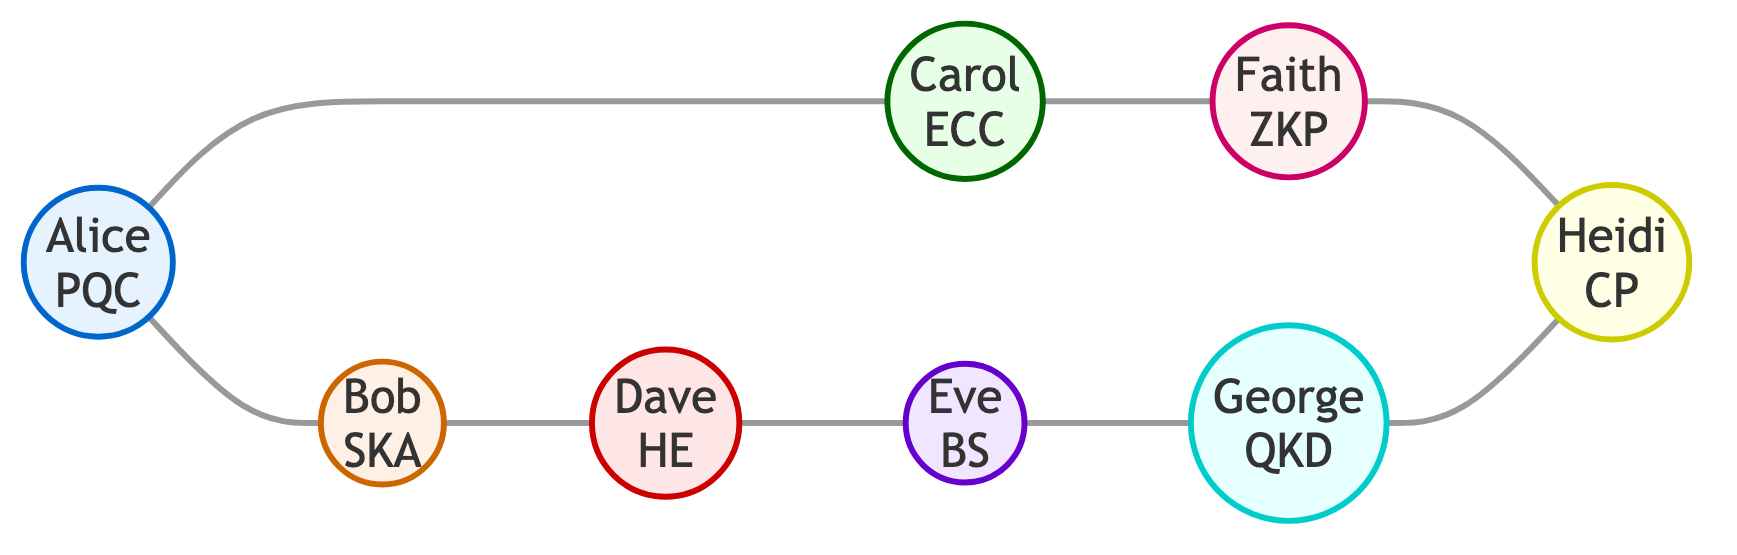What is the total number of nodes in the graph? By counting the distinct individuals represented in the diagram, we see that there are eight unique nodes: Alice, Bob, Carol, Dave, Eve, Faith, George, and Heidi.
Answer: 8 Which cryptographer collaborated with Alice? The edges connected to Alice show that she has collaborated with two individuals: Bob and Carol.
Answer: Bob and Carol What is the collaboration between Dave and Eve? The edge connecting Dave and Eve specifies that they worked together on a paper concerning homomorphic encryption for blockchain technology.
Answer: Paper on homomorphic encryption for blockchain How many different collaboration aspects are represented by the edges? Each edge in the graph represents a different aspect of collaboration between two cryptographers. There are eight edges listed, each representing one aspect of collaboration.
Answer: 8 Who collaborated with Faith? A look at the edges shows that Faith collaborated only with Heidi on a workshop related to cryptographic protocols with zero-knowledge.
Answer: Heidi Which two cryptographic fields are connected through Carol's collaboration? Carol's efforts resulted in collaborations with Faith on zero-knowledge proofs and Alice on post-quantum elliptic curves. The fields represented by these collaborations are zero-knowledge proofs and elliptic curve cryptography.
Answer: Zero-knowledge proofs and elliptic curve cryptography How many collaborations involve blockchain security? Eve's involvement includes one edge, which collaborates with Dave on a paper involving homomorphic encryption for blockchain, indicating that there is one collaboration related to blockchain security.
Answer: 1 Identify a cryptographer who works with quantum key distribution. The diagram reveals that George has collaborated with Heidi on joint research related to quantum key distribution protocols, signaling his role in this area of cryptography.
Answer: George 